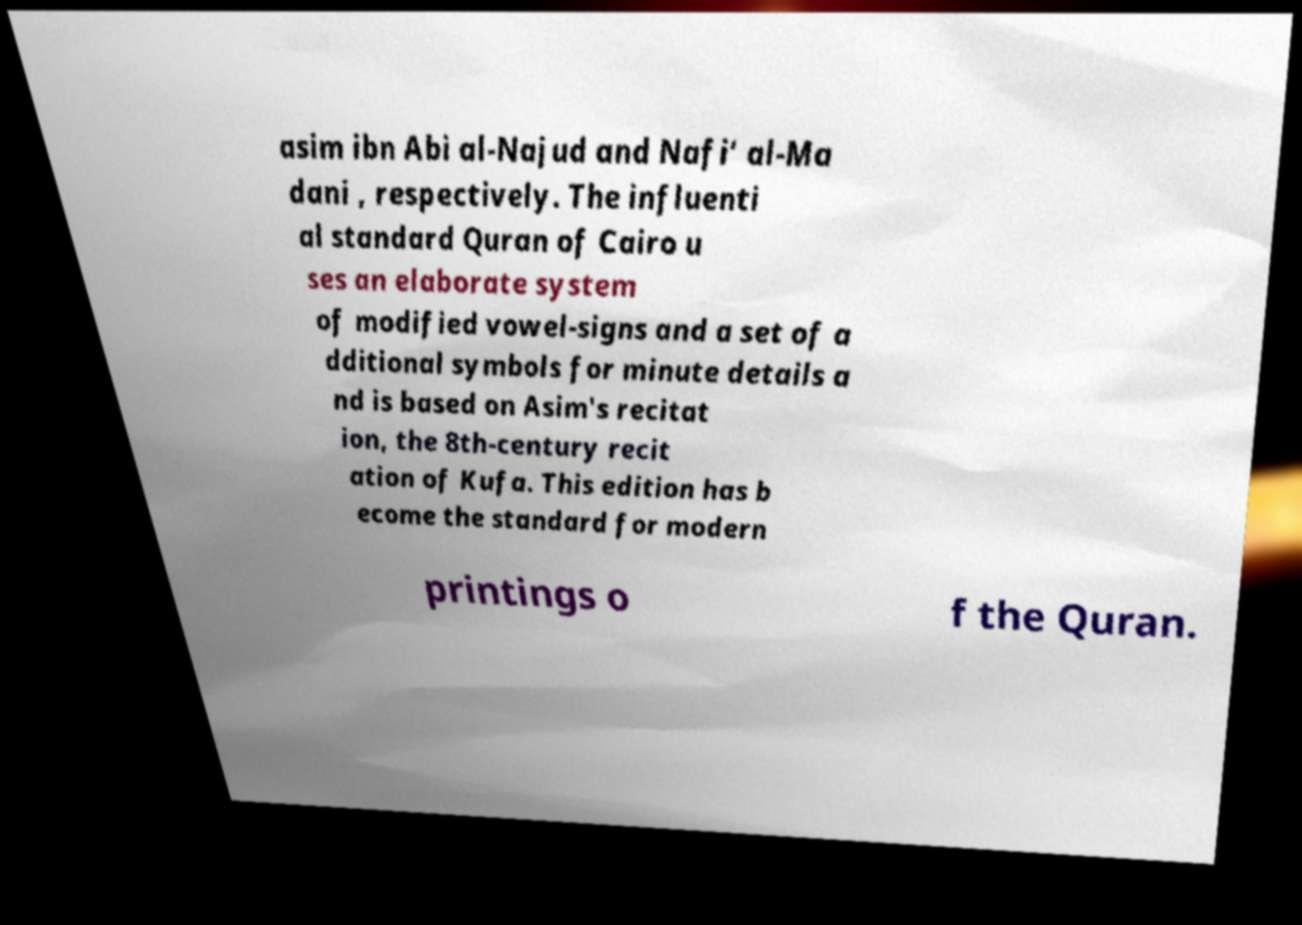There's text embedded in this image that I need extracted. Can you transcribe it verbatim? asim ibn Abi al-Najud and Nafi‘ al-Ma dani , respectively. The influenti al standard Quran of Cairo u ses an elaborate system of modified vowel-signs and a set of a dditional symbols for minute details a nd is based on Asim's recitat ion, the 8th-century recit ation of Kufa. This edition has b ecome the standard for modern printings o f the Quran. 